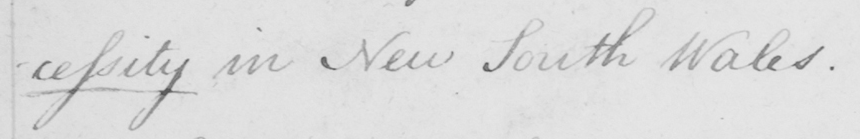What does this handwritten line say? -cessity in New South Wales . 